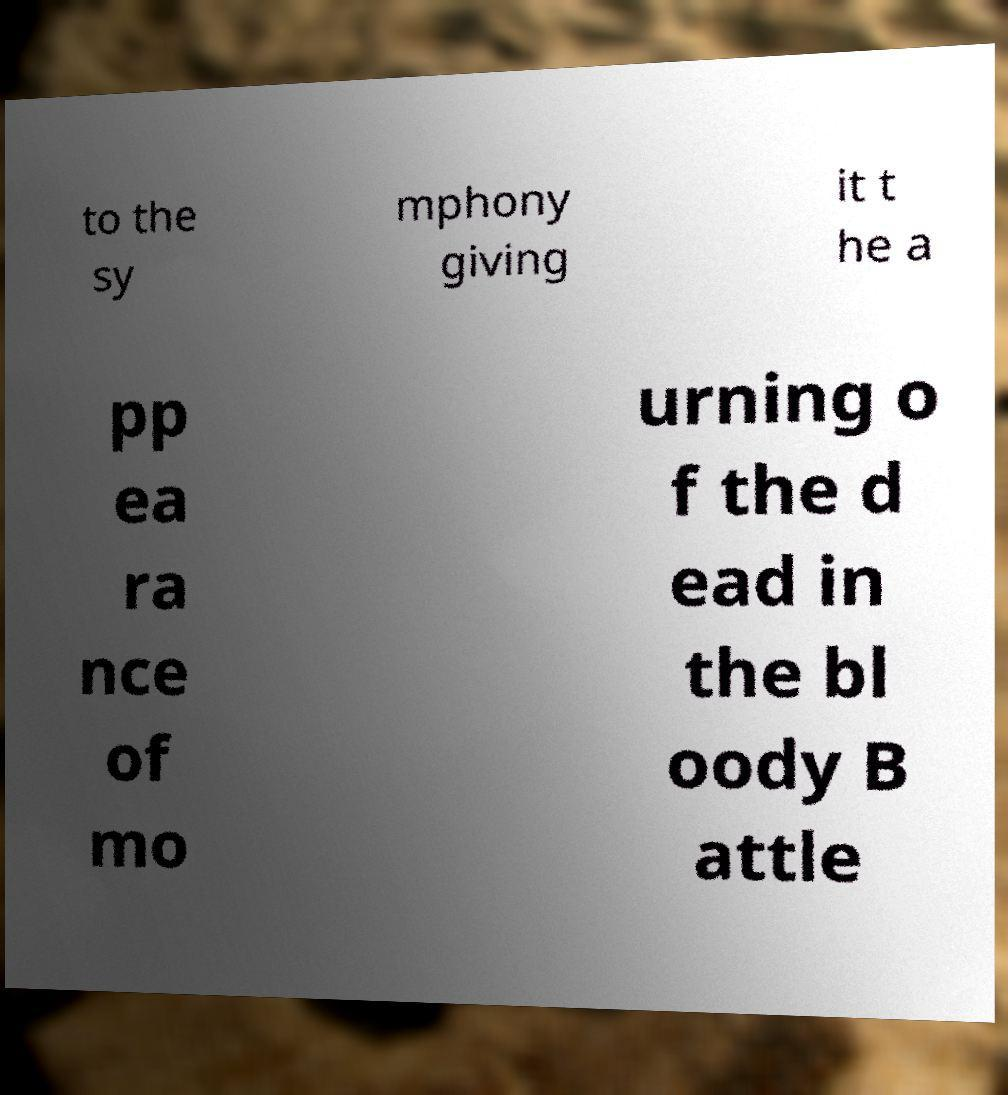Could you extract and type out the text from this image? to the sy mphony giving it t he a pp ea ra nce of mo urning o f the d ead in the bl oody B attle 